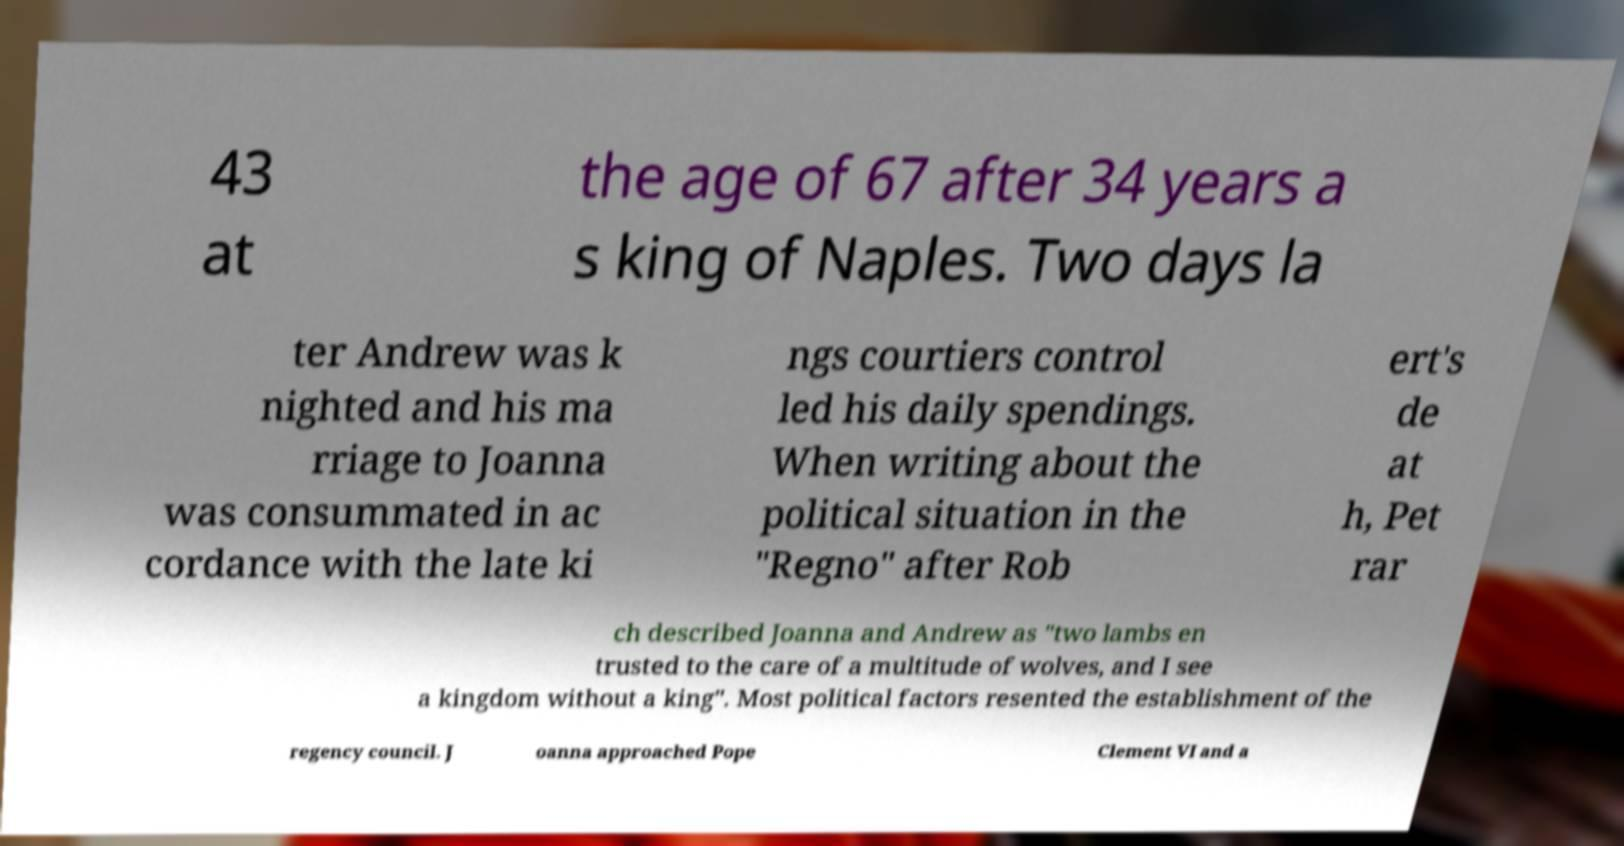Please identify and transcribe the text found in this image. 43 at the age of 67 after 34 years a s king of Naples. Two days la ter Andrew was k nighted and his ma rriage to Joanna was consummated in ac cordance with the late ki ngs courtiers control led his daily spendings. When writing about the political situation in the "Regno" after Rob ert's de at h, Pet rar ch described Joanna and Andrew as "two lambs en trusted to the care of a multitude of wolves, and I see a kingdom without a king". Most political factors resented the establishment of the regency council. J oanna approached Pope Clement VI and a 